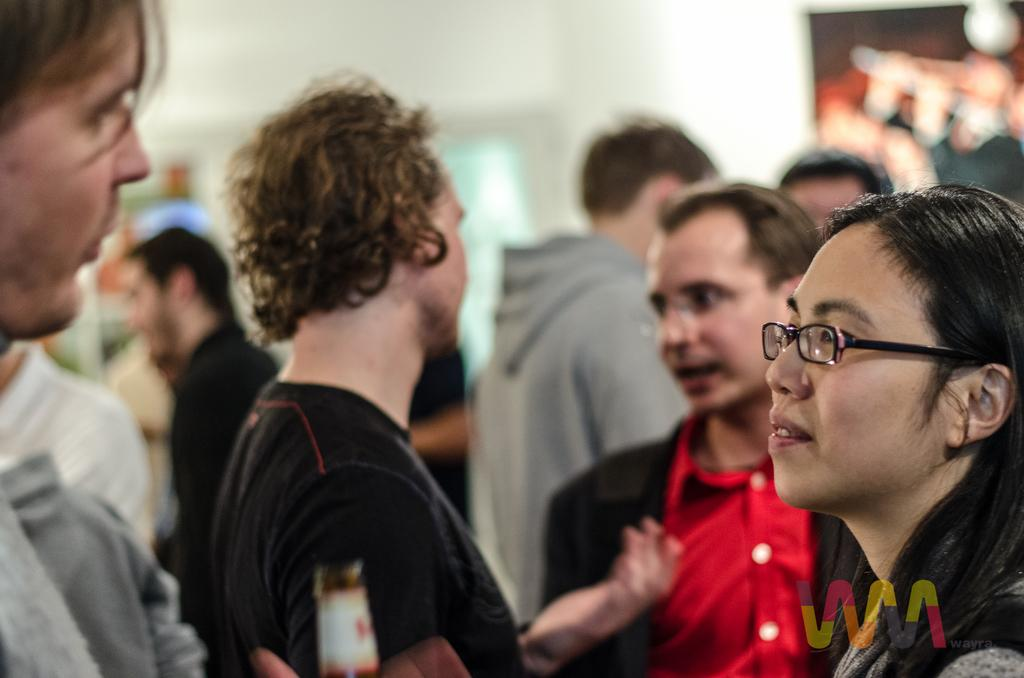How many people are in the image? There is a group of people in the image. What are the people doing in the image? The people are standing and talking with each other. What can be seen in the background of the image? There is a wall and other objects visible in the background of the image. Can you see a toothbrush being used by one of the people in the image? There is no toothbrush present in the image. What type of garden can be seen in the background of the image? There is no garden visible in the background of the image. 